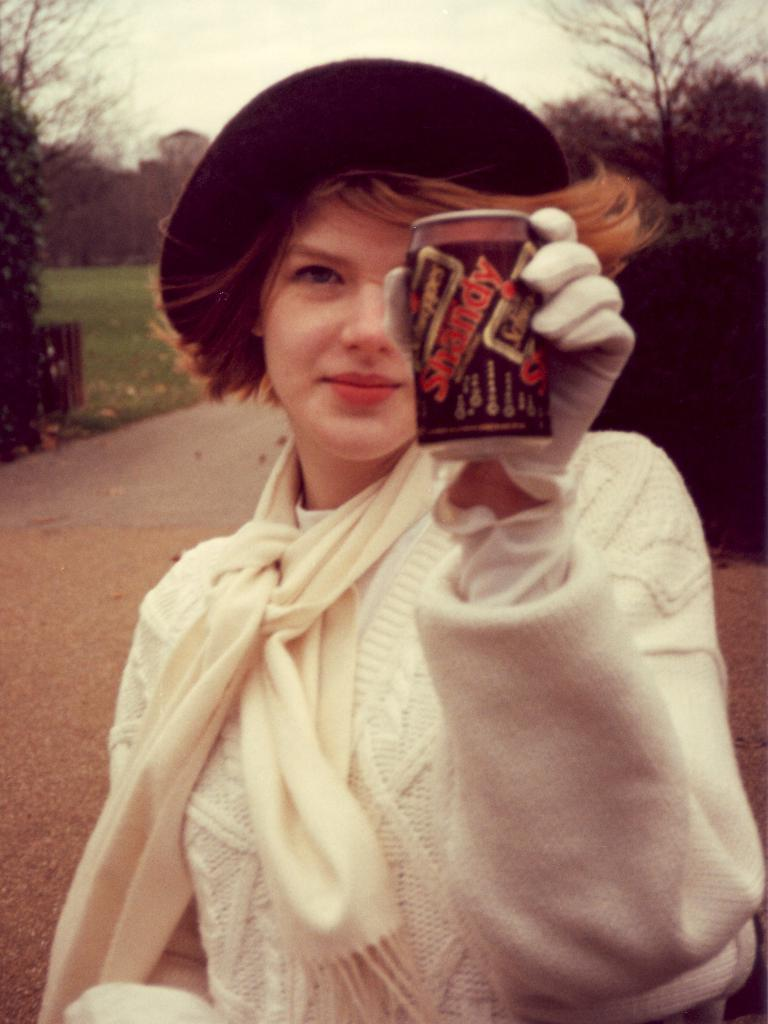Who is the main subject in the image? There is a woman in the image. What is the woman wearing on her head? The woman is wearing a hat. What object is the woman holding in her hand? The woman is holding a tin in her hand. What type of sock is the woman wearing in the image? There is no sock visible in the image; the woman is wearing a hat. 